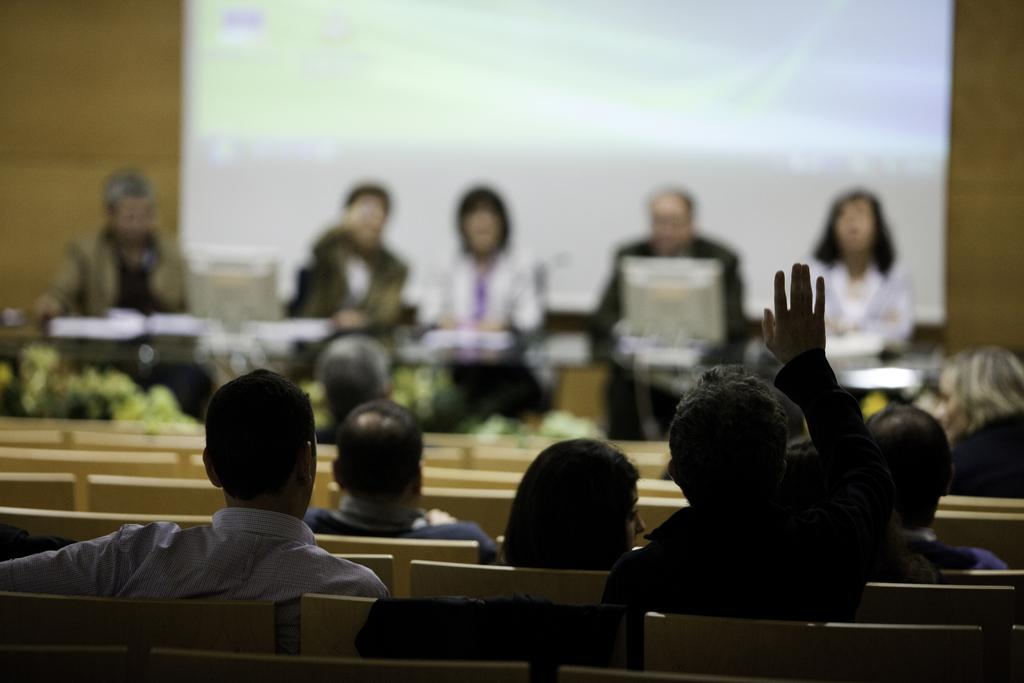What are the people in the image doing? The people in the image are sitting on chairs. What is on the table in the image? There is a table in the image, and a monitor is present on the table. What else can be seen on the table? There are objects on the table. What is attached to the wall in the image? There is a screen attached to the wall in the image. What type of jam is being tasted by the people in the image? There is no jam present in the image, and the people are not tasting anything. 